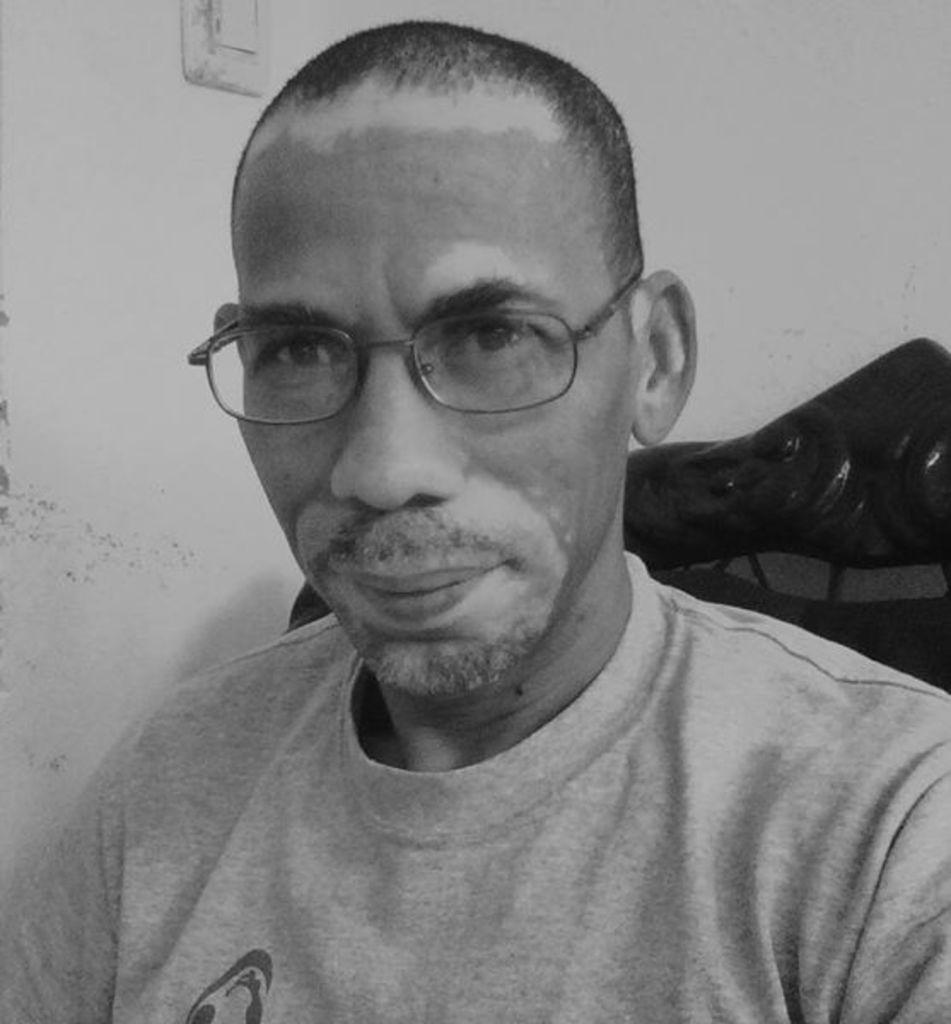What is the color scheme of the image? The image is black and white. What can be seen in the image besides the color scheme? There is a person sitting on a sofa and a wall with a switch board in the image. What type of list is being compiled by the person sitting on the sofa in the image? There is no indication in the image that the person is compiling a list or engaging in any specific behavior. 